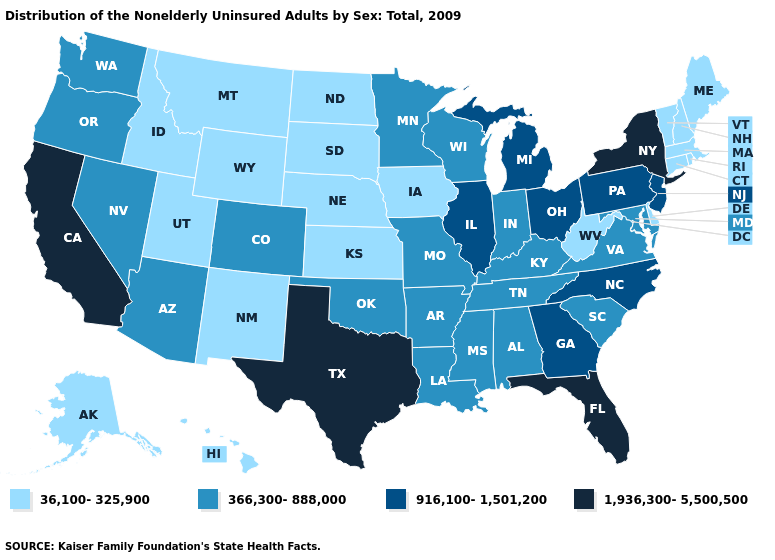Which states hav the highest value in the South?
Be succinct. Florida, Texas. Name the states that have a value in the range 916,100-1,501,200?
Quick response, please. Georgia, Illinois, Michigan, New Jersey, North Carolina, Ohio, Pennsylvania. Does Connecticut have the lowest value in the USA?
Keep it brief. Yes. Which states hav the highest value in the West?
Quick response, please. California. What is the highest value in the USA?
Be succinct. 1,936,300-5,500,500. Does Illinois have a higher value than Massachusetts?
Keep it brief. Yes. What is the highest value in the USA?
Give a very brief answer. 1,936,300-5,500,500. Does West Virginia have the highest value in the USA?
Write a very short answer. No. What is the lowest value in the USA?
Be succinct. 36,100-325,900. What is the value of Wyoming?
Be succinct. 36,100-325,900. Which states hav the highest value in the Northeast?
Be succinct. New York. What is the value of Arizona?
Be succinct. 366,300-888,000. What is the highest value in the USA?
Quick response, please. 1,936,300-5,500,500. What is the value of North Carolina?
Keep it brief. 916,100-1,501,200. 